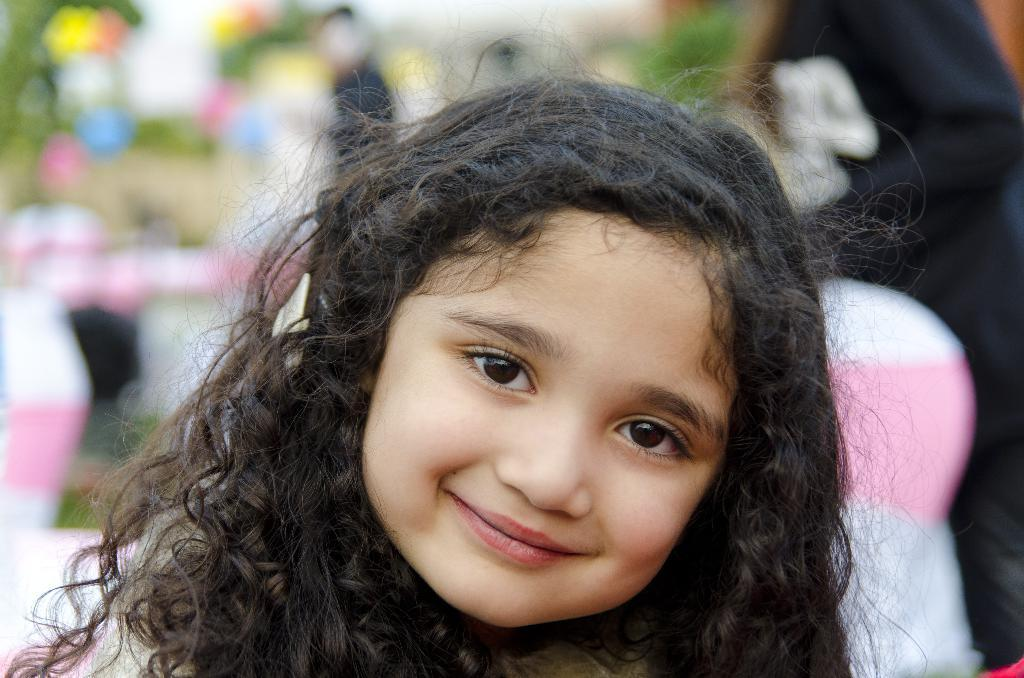Who is the main subject in the picture? There is a girl in the picture. What is the girl doing in the image? The girl is laughing. Can you describe the background of the image? The background of the image is blurred. What type of soup is the girl eating in the picture? There is no soup present in the image; the girl is laughing. What hobbies does the group of people in the image share? There is no group of people in the image; it only features a girl. 